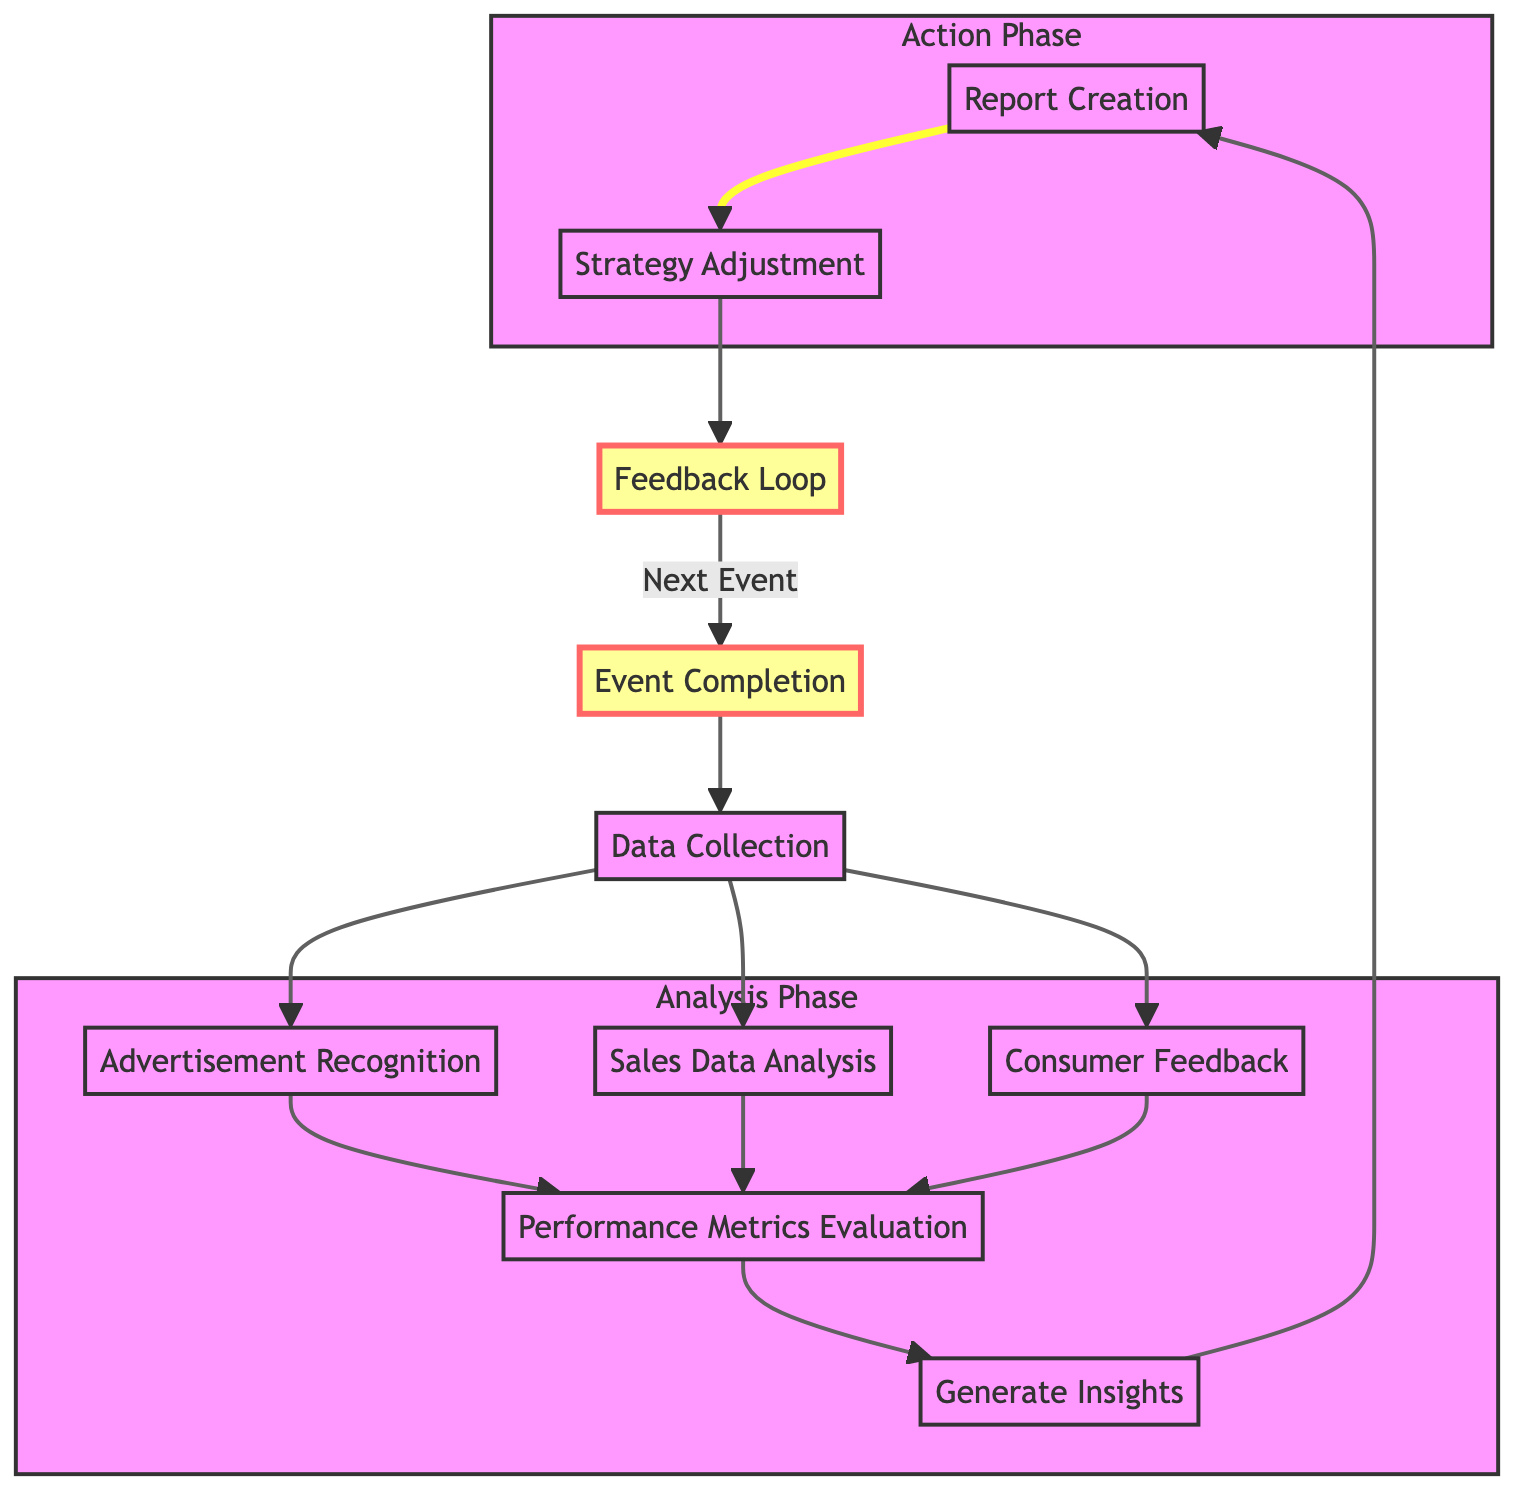What is the first stage in the flowchart? The flowchart starts at the "Event Completion" node, indicated as the first stage where all activities commence post-event.
Answer: Event Completion How many stages are included in the diagram? Counting each distinct stage listed in the flowchart, we find there are ten individual stages from "Event Completion" to "Feedback Loop."
Answer: 10 What stage comes after "Performance Metrics Evaluation"? Following "Performance Metrics Evaluation," the next stage in the flowchart is "Generate Insights," which analyzes the data collected for further insights.
Answer: Generate Insights Which stages involve data collection? Three stages are specifically focused on data collection: "Advertisement Recognition," "Sales Data Analysis," and "Consumer Feedback," all stemming from "Data Collection."
Answer: Advertisement Recognition, Sales Data Analysis, Consumer Feedback Which stage is highlighted in green? The "Feedback Loop" is highlighted in green, indicating its importance in ensuring continuous improvement after each combat sports event.
Answer: Feedback Loop What happens after "Report Creation"? After "Report Creation," the flow goes to "Strategy Adjustment," where advertising strategies are updated based on the report findings.
Answer: Strategy Adjustment Can you name the last stage that connects back to "Event Completion"? The last stage that connects back to "Event Completion" is the "Feedback Loop," signifying the return to the beginning for ongoing improvement.
Answer: Feedback Loop How many edges are there leading out of "Data Collection"? There are three edges leading out of "Data Collection," connecting to "Advertisement Recognition," "Sales Data Analysis," and "Consumer Feedback."
Answer: 3 What is the purpose of the report created in the flowchart? The report created summarizes advertisement effectiveness and includes visual aids to support the analysis drawn from various data insights.
Answer: Summarize advertisement effectiveness Which software is suggested for analysis in the "Generate Insights" stage? The flowchart suggests using software like Tableau or Power BI for visualizing and analyzing the collected data to derive insights.
Answer: Tableau or Power BI 